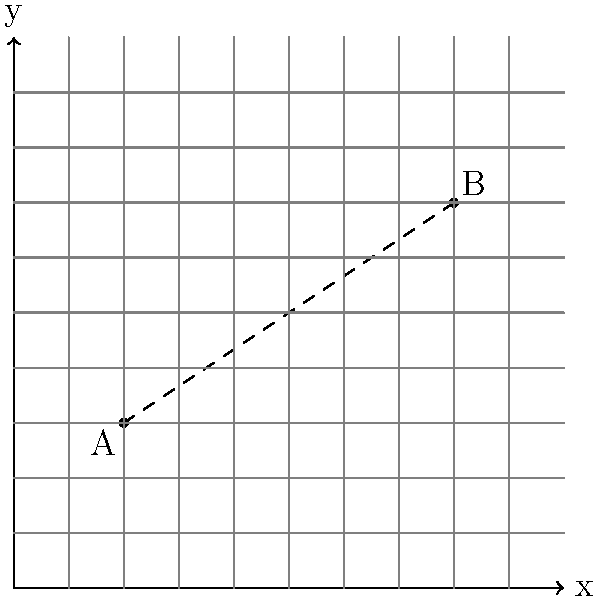In your research for a biography about an unsung hero of urban planning, you've come across a map of a historic city represented on a coordinate plane. Two significant locations in the hero's life story are marked as points A(2,3) and B(8,7). Calculate the straight-line distance between these two locations to understand the scale of the hero's impact on the city's development. To find the distance between two points on a coordinate plane, we can use the distance formula, which is derived from the Pythagorean theorem:

$$ d = \sqrt{(x_2 - x_1)^2 + (y_2 - y_1)^2} $$

Where $(x_1, y_1)$ are the coordinates of the first point and $(x_2, y_2)$ are the coordinates of the second point.

Given:
Point A: $(2, 3)$
Point B: $(8, 7)$

Let's plug these values into the formula:

$$ d = \sqrt{(8 - 2)^2 + (7 - 3)^2} $$

Now, let's solve step by step:

1) First, calculate the differences:
   $$ d = \sqrt{(6)^2 + (4)^2} $$

2) Square the differences:
   $$ d = \sqrt{36 + 16} $$

3) Add the squared differences:
   $$ d = \sqrt{52} $$

4) Simplify the square root:
   $$ d = 2\sqrt{13} $$

Therefore, the distance between points A and B is $2\sqrt{13}$ units.
Answer: $2\sqrt{13}$ units 